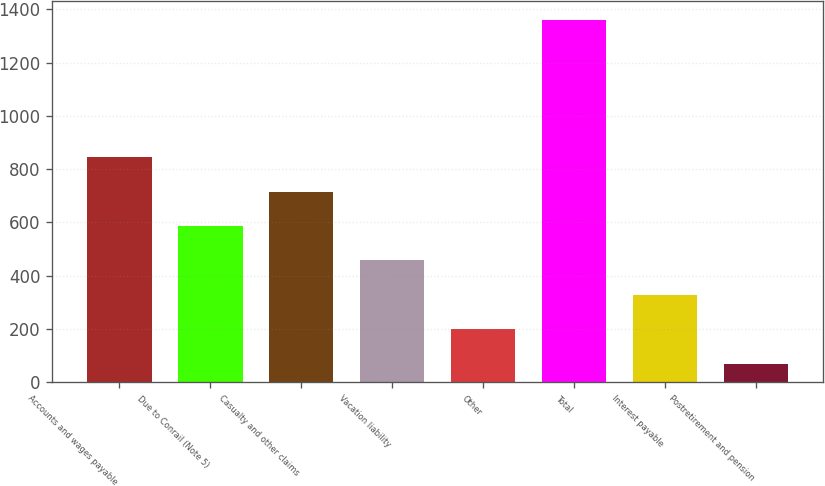Convert chart. <chart><loc_0><loc_0><loc_500><loc_500><bar_chart><fcel>Accounts and wages payable<fcel>Due to Conrail (Note 5)<fcel>Casualty and other claims<fcel>Vacation liability<fcel>Other<fcel>Total<fcel>Interest payable<fcel>Postretirement and pension<nl><fcel>845.2<fcel>586.8<fcel>716<fcel>457.6<fcel>199.2<fcel>1362<fcel>328.4<fcel>70<nl></chart> 